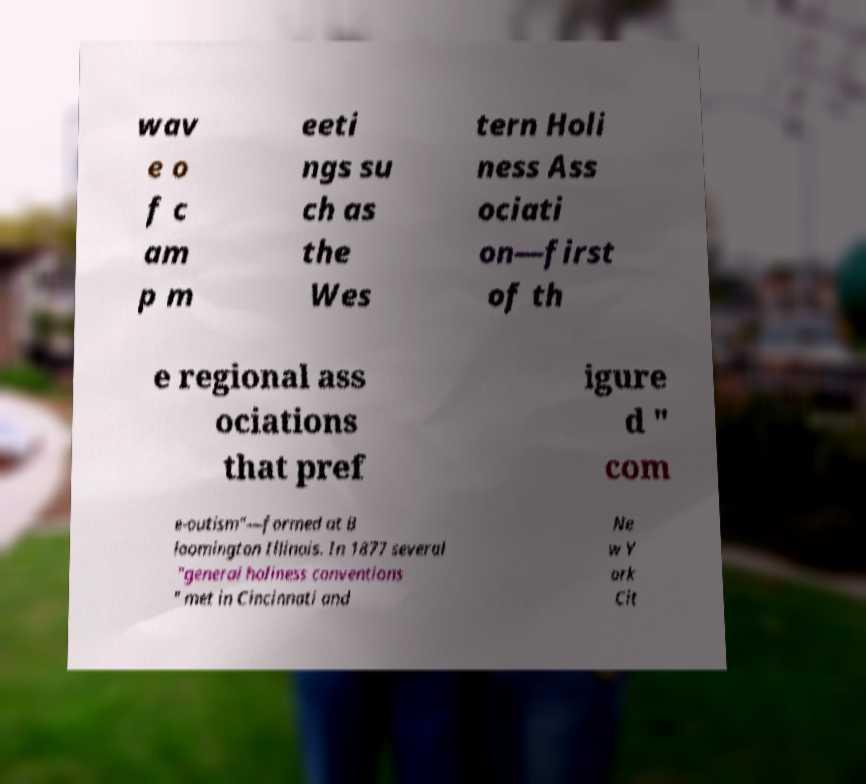Please identify and transcribe the text found in this image. wav e o f c am p m eeti ngs su ch as the Wes tern Holi ness Ass ociati on—first of th e regional ass ociations that pref igure d " com e-outism"—formed at B loomington Illinois. In 1877 several "general holiness conventions " met in Cincinnati and Ne w Y ork Cit 